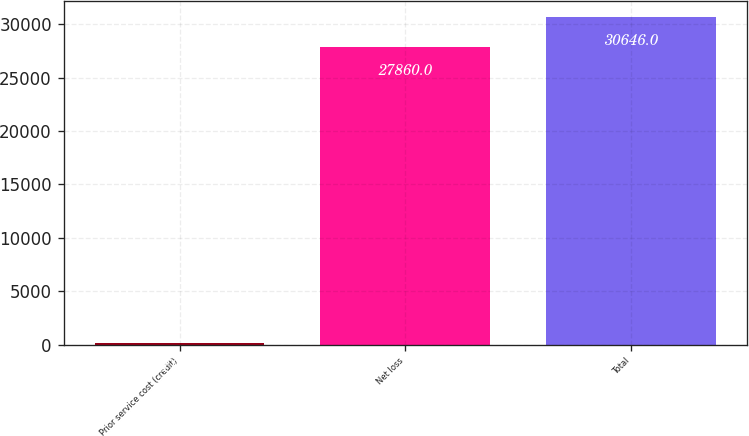Convert chart to OTSL. <chart><loc_0><loc_0><loc_500><loc_500><bar_chart><fcel>Prior service cost (credit)<fcel>Net loss<fcel>Total<nl><fcel>110<fcel>27860<fcel>30646<nl></chart> 